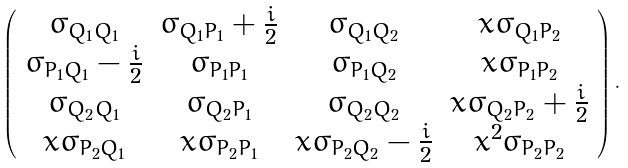Convert formula to latex. <formula><loc_0><loc_0><loc_500><loc_500>\left ( \begin{array} { c c c c } \sigma _ { Q _ { 1 } Q _ { 1 } } & \sigma _ { Q _ { 1 } P _ { 1 } } + \frac { i } { 2 } & \sigma _ { Q _ { 1 } Q _ { 2 } } & x \sigma _ { Q _ { 1 } P _ { 2 } } \\ \sigma _ { P _ { 1 } Q _ { 1 } } - \frac { i } { 2 } & \sigma _ { P _ { 1 } P _ { 1 } } & \sigma _ { P _ { 1 } Q _ { 2 } } & x \sigma _ { P _ { 1 } P _ { 2 } } \\ \sigma _ { Q _ { 2 } Q _ { 1 } } & \sigma _ { Q _ { 2 } P _ { 1 } } & \sigma _ { Q _ { 2 } Q _ { 2 } } & x \sigma _ { Q _ { 2 } P _ { 2 } } + \frac { i } { 2 } \\ x \sigma _ { P _ { 2 } Q _ { 1 } } & x \sigma _ { P _ { 2 } P _ { 1 } } & x \sigma _ { P _ { 2 } Q _ { 2 } } - \frac { i } { 2 } & x ^ { 2 } \sigma _ { P _ { 2 } P _ { 2 } } \end{array} \right ) .</formula> 